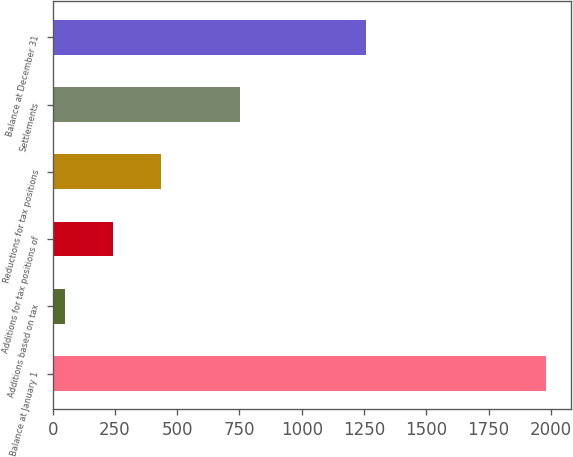Convert chart to OTSL. <chart><loc_0><loc_0><loc_500><loc_500><bar_chart><fcel>Balance at January 1<fcel>Additions based on tax<fcel>Additions for tax positions of<fcel>Reductions for tax positions<fcel>Settlements<fcel>Balance at December 31<nl><fcel>1982<fcel>50<fcel>243.2<fcel>436.4<fcel>753<fcel>1259<nl></chart> 